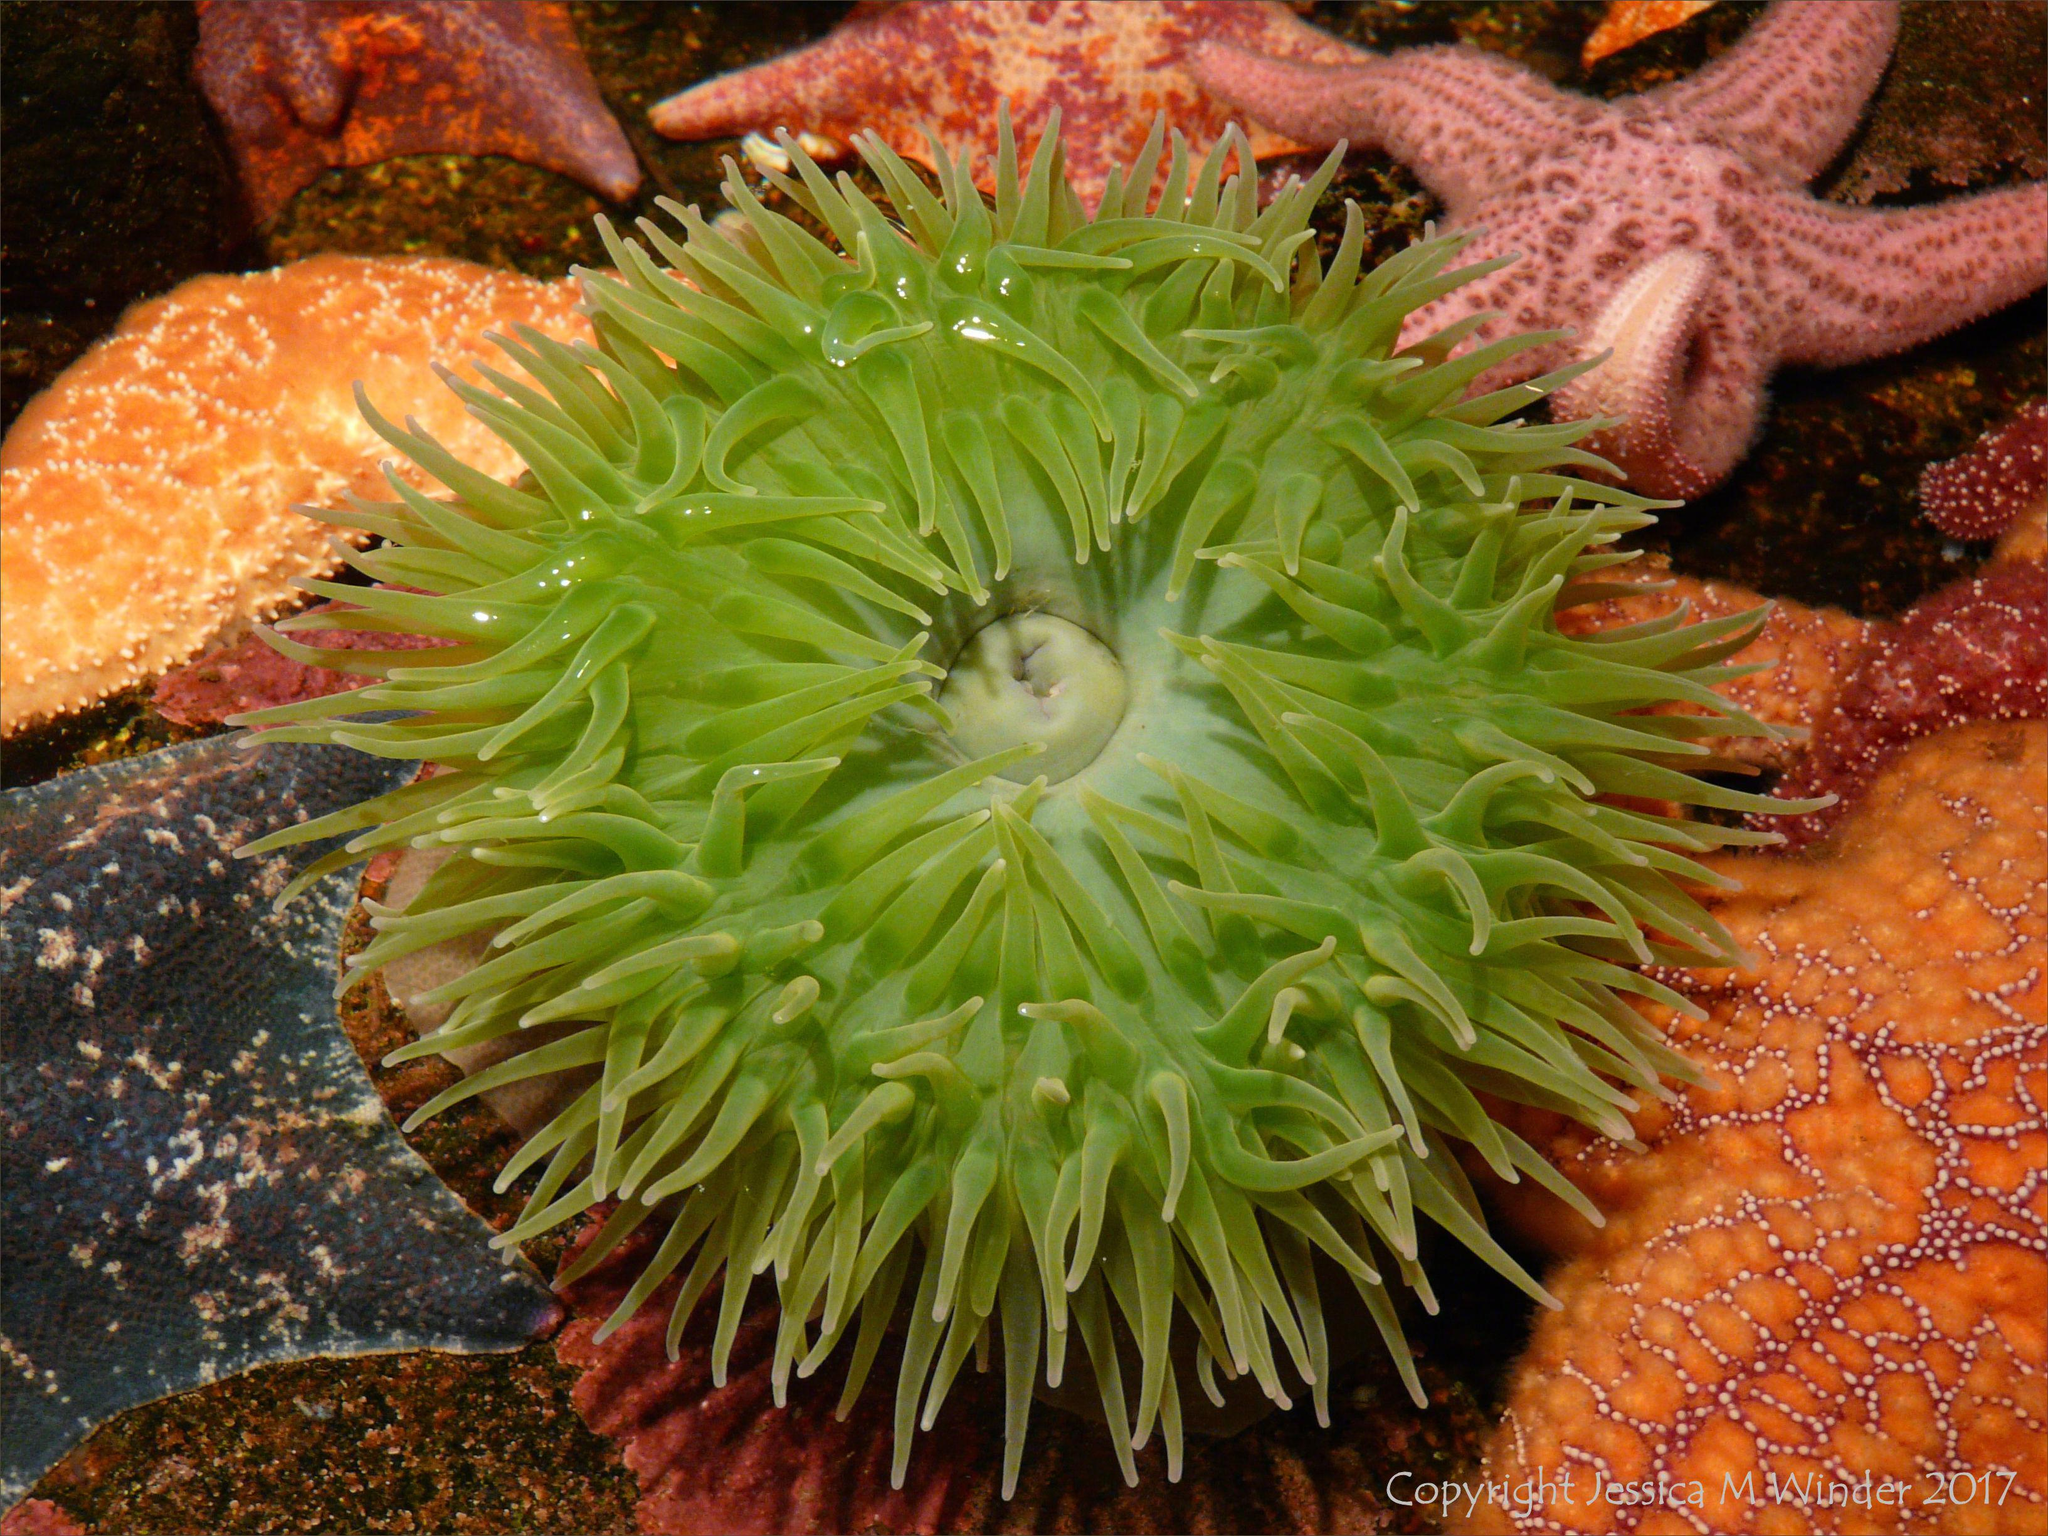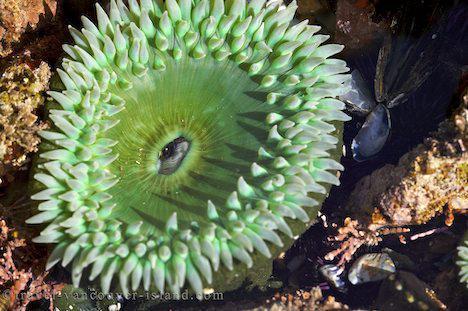The first image is the image on the left, the second image is the image on the right. Analyze the images presented: Is the assertion "Right image features at least one anemone with a green tint." valid? Answer yes or no. Yes. The first image is the image on the left, the second image is the image on the right. Analyze the images presented: Is the assertion "There are at least two anemones in one of the images." valid? Answer yes or no. No. 